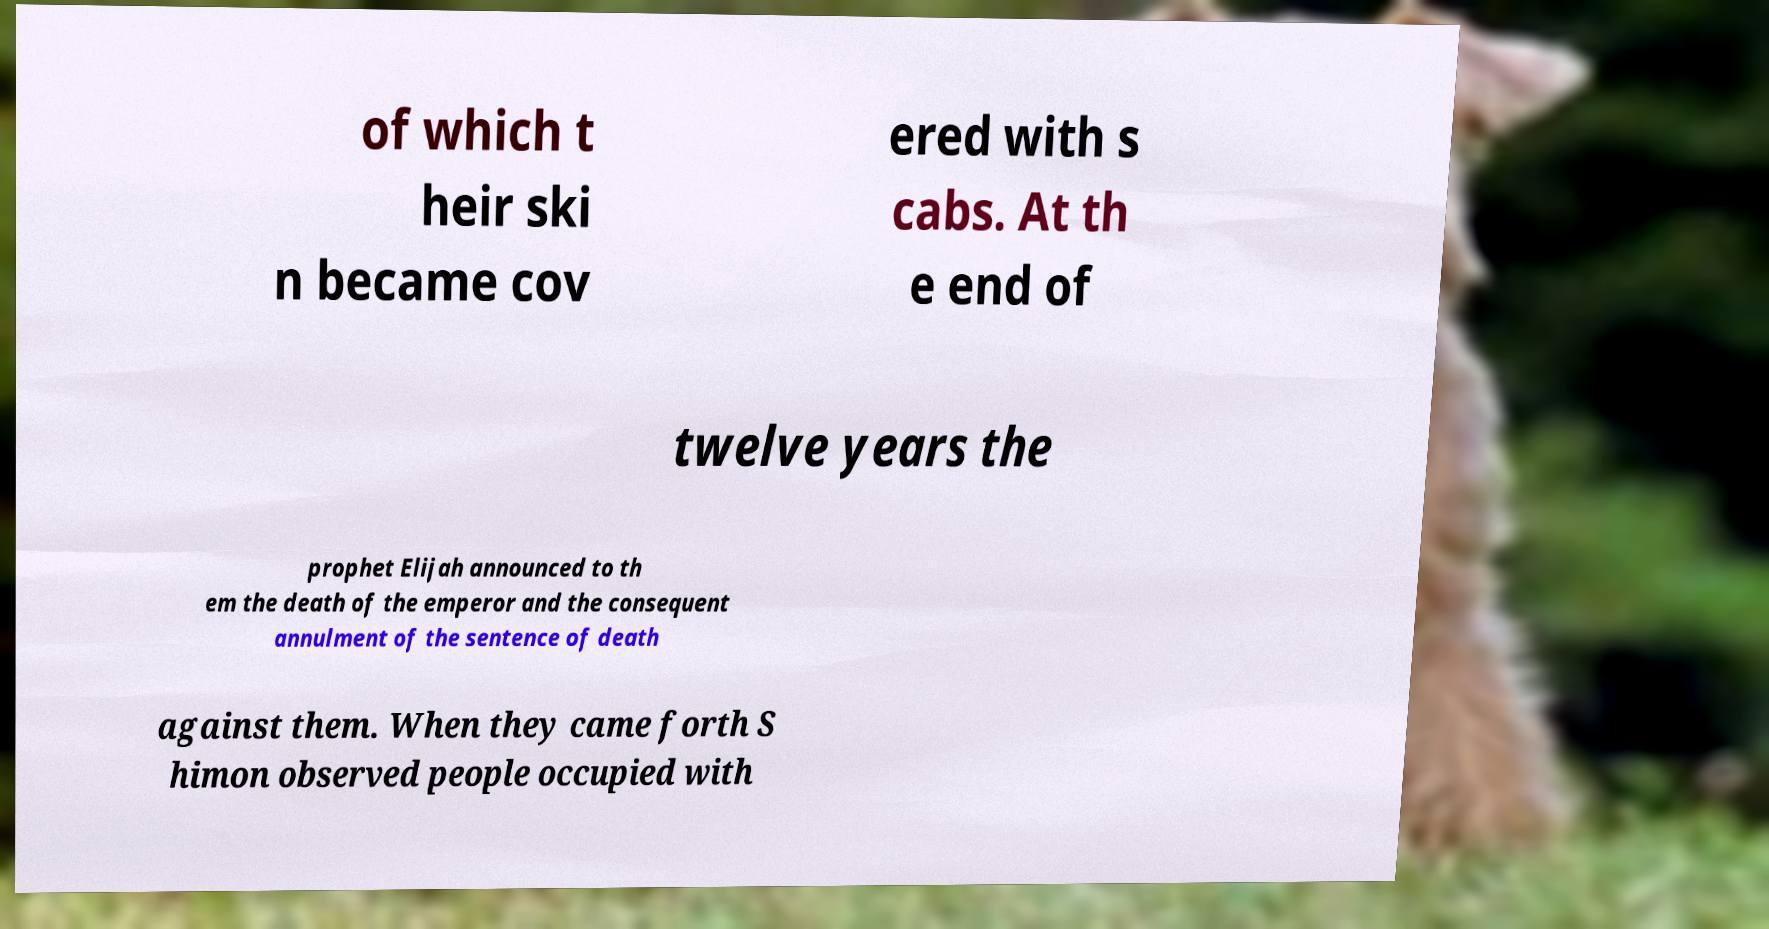Can you read and provide the text displayed in the image?This photo seems to have some interesting text. Can you extract and type it out for me? of which t heir ski n became cov ered with s cabs. At th e end of twelve years the prophet Elijah announced to th em the death of the emperor and the consequent annulment of the sentence of death against them. When they came forth S himon observed people occupied with 